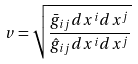Convert formula to latex. <formula><loc_0><loc_0><loc_500><loc_500>v = \sqrt { \frac { \bar { g } _ { i j } d x ^ { i } d x ^ { j } } { \hat { g } _ { i j } d x ^ { i } d x ^ { j } } }</formula> 